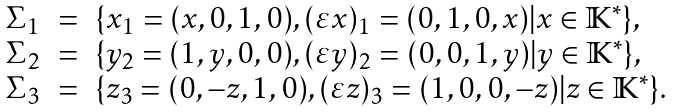<formula> <loc_0><loc_0><loc_500><loc_500>\begin{array} { r c l } \Sigma _ { 1 } & = & \{ x _ { 1 } = ( x , 0 , 1 , 0 ) , ( \varepsilon x ) _ { 1 } = ( 0 , 1 , 0 , x ) | x \in \mathbb { K } ^ { * } \} , \\ \Sigma _ { 2 } & = & \{ y _ { 2 } = ( 1 , y , 0 , 0 ) , ( \varepsilon y ) _ { 2 } = ( 0 , 0 , 1 , y ) | y \in \mathbb { K } ^ { * } \} , \\ \Sigma _ { 3 } & = & \{ z _ { 3 } = ( 0 , - z , 1 , 0 ) , ( \varepsilon z ) _ { 3 } = ( 1 , 0 , 0 , - z ) | z \in \mathbb { K } ^ { * } \} . \\ \end{array}</formula> 